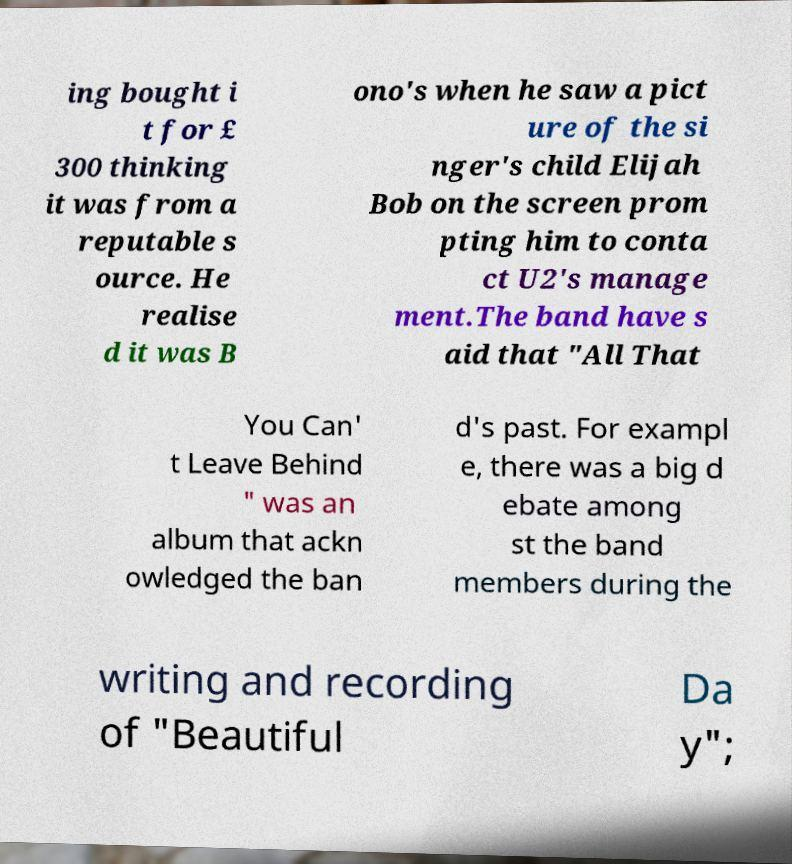Can you read and provide the text displayed in the image?This photo seems to have some interesting text. Can you extract and type it out for me? ing bought i t for £ 300 thinking it was from a reputable s ource. He realise d it was B ono's when he saw a pict ure of the si nger's child Elijah Bob on the screen prom pting him to conta ct U2's manage ment.The band have s aid that "All That You Can' t Leave Behind " was an album that ackn owledged the ban d's past. For exampl e, there was a big d ebate among st the band members during the writing and recording of "Beautiful Da y"; 